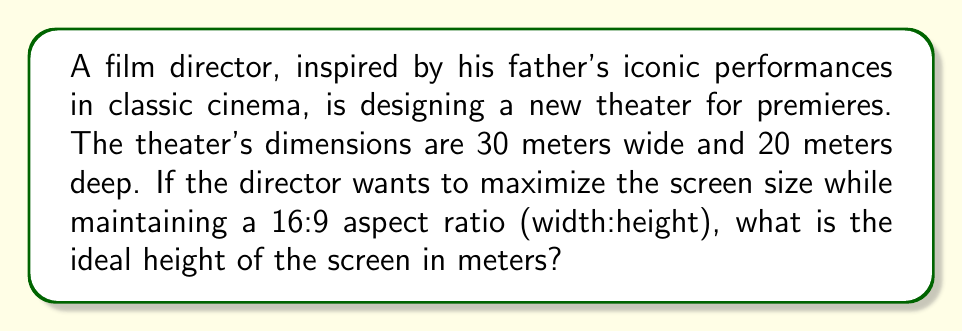Can you solve this math problem? Let's approach this step-by-step:

1) First, we need to understand the constraint. The screen must fit within the theater's width of 30 meters.

2) We know the aspect ratio is 16:9, which means:
   $\frac{\text{width}}{\text{height}} = \frac{16}{9}$

3) Let's define variables:
   $w$ = width of the screen
   $h$ = height of the screen

4) We can express the relationship between width and height:
   $\frac{w}{h} = \frac{16}{9}$

5) Cross multiply:
   $9w = 16h$

6) Solve for $w$:
   $w = \frac{16h}{9}$

7) Now, we know the maximum width is 30 meters. So:
   $30 = \frac{16h}{9}$

8) Solve for $h$:
   $30 * 9 = 16h$
   $270 = 16h$
   $h = \frac{270}{16} = 16.875$

Therefore, the ideal height of the screen is 16.875 meters.
Answer: $16.875$ meters 